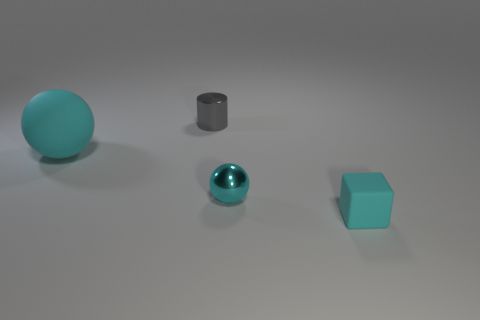Add 4 tiny gray shiny things. How many objects exist? 8 Subtract all cylinders. How many objects are left? 3 Subtract 0 purple cubes. How many objects are left? 4 Subtract all tiny gray shiny cylinders. Subtract all gray cylinders. How many objects are left? 2 Add 4 gray cylinders. How many gray cylinders are left? 5 Add 4 large shiny spheres. How many large shiny spheres exist? 4 